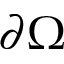<formula> <loc_0><loc_0><loc_500><loc_500>\partial \Omega</formula> 